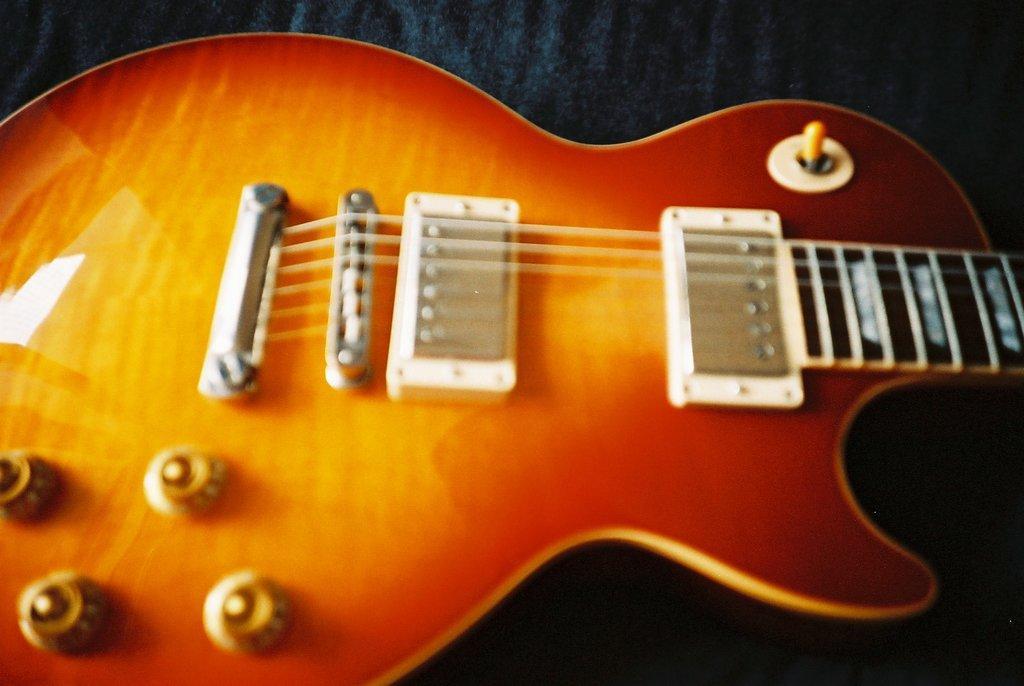Can you describe this image briefly? In this image I see a guitar which is of orange and red in color and I see the strings on it and this guitar is on a black surface. 